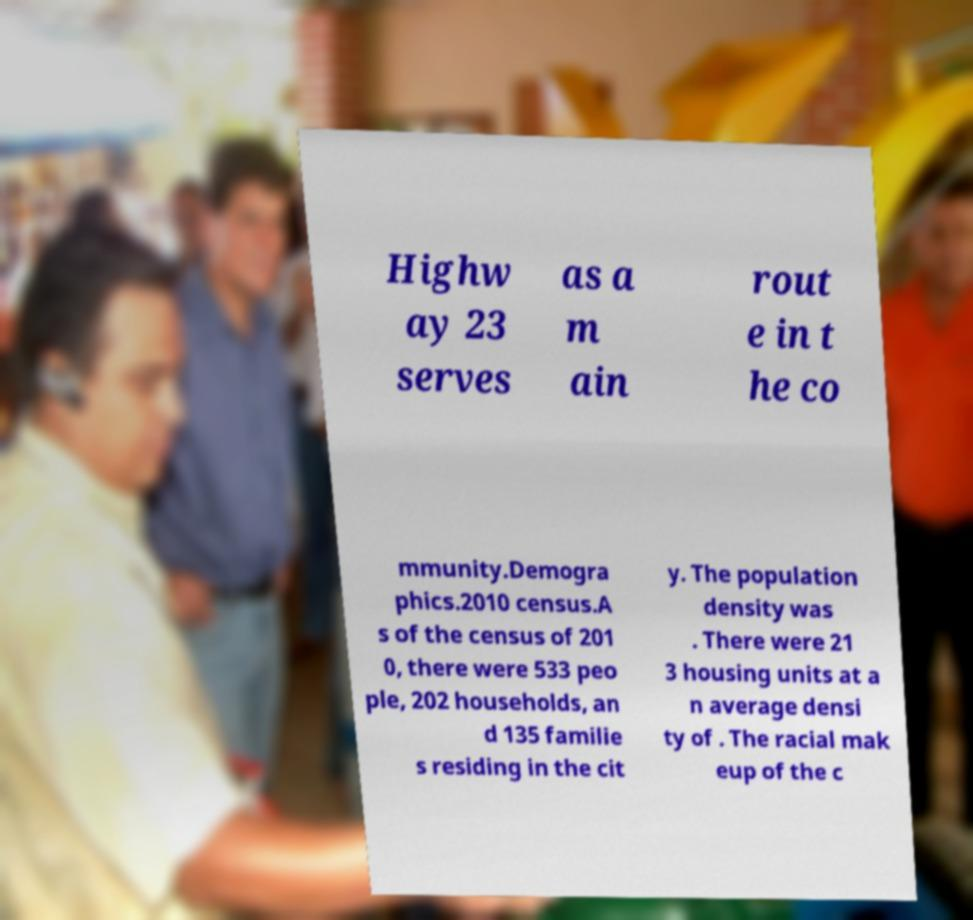I need the written content from this picture converted into text. Can you do that? Highw ay 23 serves as a m ain rout e in t he co mmunity.Demogra phics.2010 census.A s of the census of 201 0, there were 533 peo ple, 202 households, an d 135 familie s residing in the cit y. The population density was . There were 21 3 housing units at a n average densi ty of . The racial mak eup of the c 